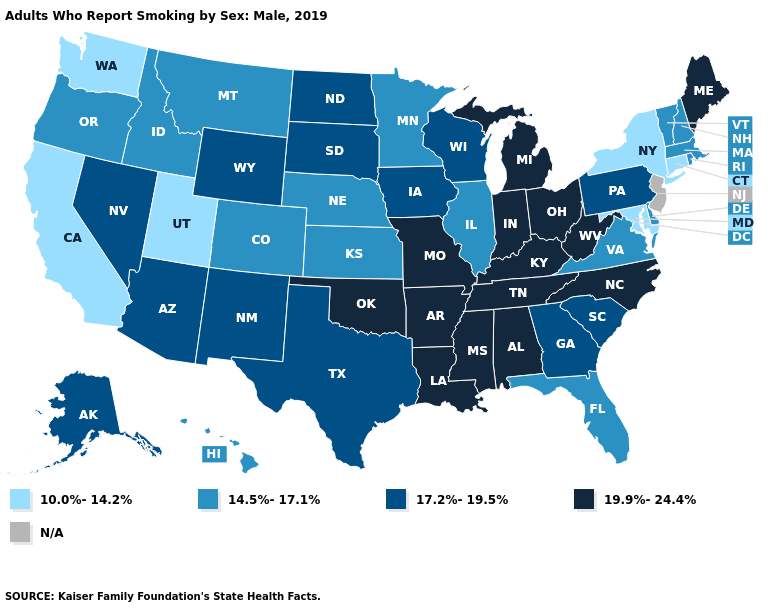Name the states that have a value in the range N/A?
Short answer required. New Jersey. What is the value of Arkansas?
Give a very brief answer. 19.9%-24.4%. Name the states that have a value in the range 19.9%-24.4%?
Give a very brief answer. Alabama, Arkansas, Indiana, Kentucky, Louisiana, Maine, Michigan, Mississippi, Missouri, North Carolina, Ohio, Oklahoma, Tennessee, West Virginia. Among the states that border Utah , which have the highest value?
Be succinct. Arizona, Nevada, New Mexico, Wyoming. Does Pennsylvania have the lowest value in the Northeast?
Answer briefly. No. Is the legend a continuous bar?
Be succinct. No. Does the map have missing data?
Concise answer only. Yes. What is the lowest value in the USA?
Answer briefly. 10.0%-14.2%. Does South Carolina have the highest value in the USA?
Keep it brief. No. What is the highest value in the USA?
Keep it brief. 19.9%-24.4%. Name the states that have a value in the range 17.2%-19.5%?
Give a very brief answer. Alaska, Arizona, Georgia, Iowa, Nevada, New Mexico, North Dakota, Pennsylvania, South Carolina, South Dakota, Texas, Wisconsin, Wyoming. Name the states that have a value in the range N/A?
Give a very brief answer. New Jersey. Does California have the lowest value in the West?
Short answer required. Yes. Does Oklahoma have the highest value in the South?
Write a very short answer. Yes. 